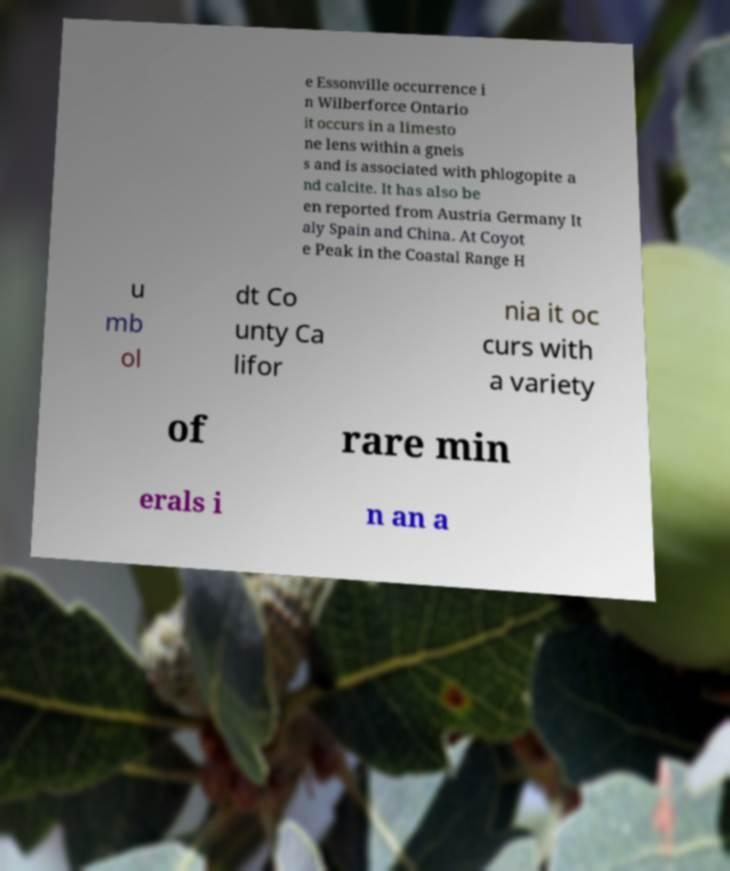Could you extract and type out the text from this image? e Essonville occurrence i n Wilberforce Ontario it occurs in a limesto ne lens within a gneis s and is associated with phlogopite a nd calcite. It has also be en reported from Austria Germany It aly Spain and China. At Coyot e Peak in the Coastal Range H u mb ol dt Co unty Ca lifor nia it oc curs with a variety of rare min erals i n an a 